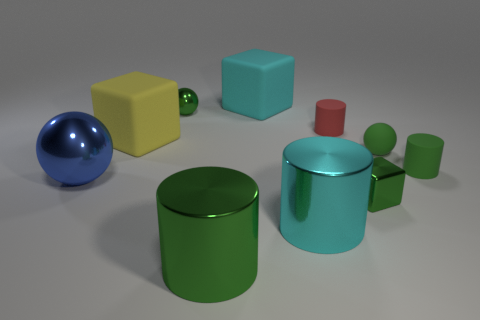Subtract all cylinders. How many objects are left? 6 Subtract all spheres. Subtract all small green blocks. How many objects are left? 6 Add 9 tiny green blocks. How many tiny green blocks are left? 10 Add 6 large cyan rubber objects. How many large cyan rubber objects exist? 7 Subtract 1 cyan blocks. How many objects are left? 9 